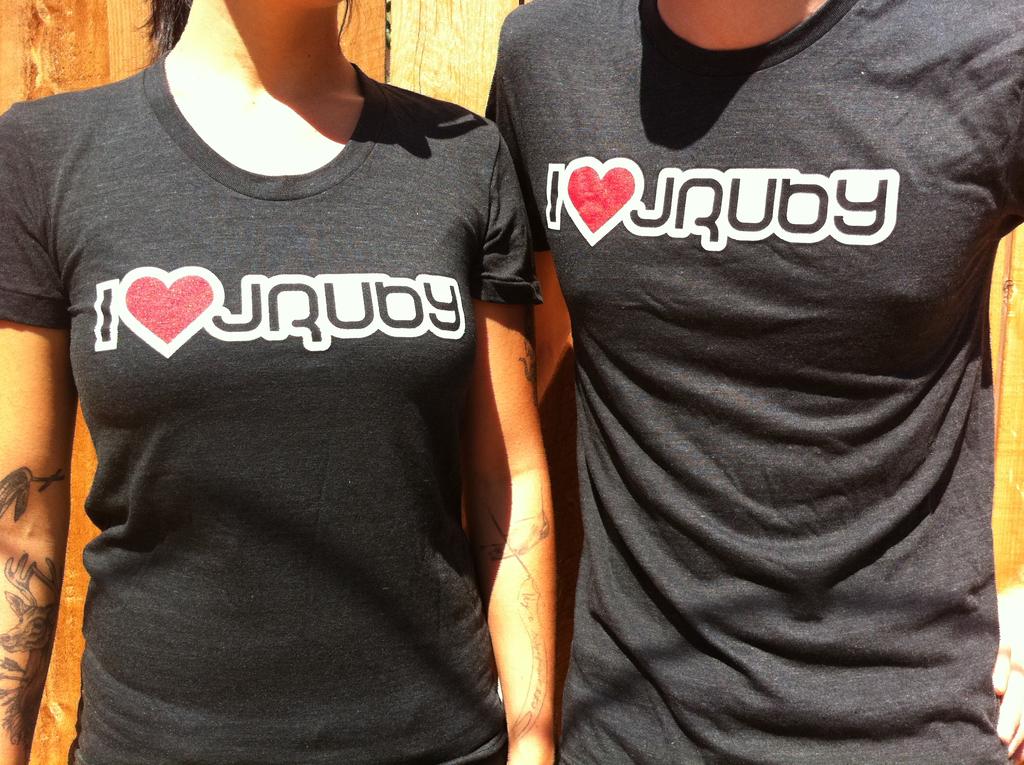What color are the letters on the shirts?
Ensure brevity in your answer.  Black. What words are written on both of their shirts?
Provide a short and direct response. I jruby. 